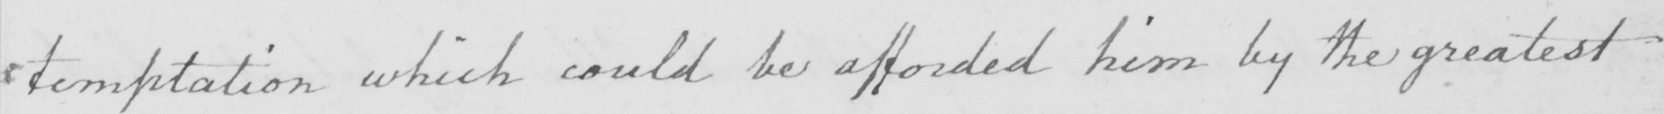What does this handwritten line say? temptation which could be afforded him by the greatest 